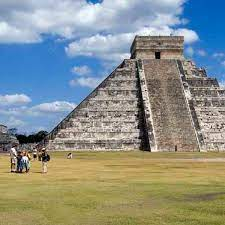Explain the architectural significance of Chichen Itza. Chichen Itza, particularly its iconic Pyramid of Kukulkan (also known as El Castillo), is a prime example of Mayan architecture and its alignment with astronomical events. The pyramid is known for its precise design, where each of its four sides has 91 steps which, combined with the top platform, total 365 steps, representing the days of the year. The pyramid’s construction is also aligned with the solar cycles; during the equinoxes, the sun casts a shadow on the side of the pyramid that resembles a serpent descending the steps, symbolizing the feathered serpent god Kukulkan. This interplay of light and shadow illustrated the Mayans' advanced knowledge of astronomy and their ability to integrate it into their architectural designs. What evidence supports the theory that Chichen Itza was an ancient hub of astronomical study? Several aspects of Chichen Itza’s architecture support the theory that it was an ancient hub for astronomical study. Firstly, the Pyramid of Kukulkan itself is a giant calendar, with its structural design reflecting the solar year and the equinoxes. Additionally, the Caracol, or the Observatory, is another significant structure at Chichen Itza with its circular tower and spiral staircase, believed to be used for astronomical observations. Its windows are aligned with key celestial events, such as the path of Venus and the solstices. These structures, combined with Mayan hieroglyphs and codices that include detailed astronomical charts, indicate the level of sophistication and importance the Mayans placed on celestial observations. 